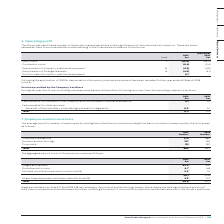According to Auto Trader's financial document, Why are some of the items identified by the group considered material? due to the significance of their nature and/or amount. These are listed separately here to provide a better understanding of the financial performance of the Group. The document states: "s identified a number of items which are material due to the significance of their nature and/or amount. These are listed separately here to provide a..." Also, What item in the table has been restated for 2018? Following the application of IFRS 16, depreciation of property, plant and equipment has been restated. The document states: "Following the application of IFRS 16, depreciation of property, plant and equipment has been restated for the year ended 31 March 2018 (note 2)...." Also, For which years was Depreciation of property, plant and equipment calculated? The document shows two values: 2019 and 2018. From the document: "Group plc Annual Report and Financial Statements 2019 | 103 (Restated) 2018 £m..." Additionally, In which year were staff costs larger? According to the financial document, 2019. The relevant text states: "Group plc Annual Report and Financial Statements 2019 | 103..." Also, can you calculate: What was the change in staff costs in 2019 from 2018? Based on the calculation: -56.0-(-54.5), the result is -1.5 (in millions). This is based on the information: "Staff costs 7 (56.0) (54.5) Staff costs 7 (56.0) (54.5)..." The key data points involved are: 54.5, 56.0. Also, can you calculate: What was the percentage change in staff costs in 2019 from 2018? To answer this question, I need to perform calculations using the financial data. The calculation is: (-56.0-(-54.5))/-54.5, which equals 2.75 (percentage). This is based on the information: "Staff costs 7 (56.0) (54.5) Staff costs 7 (56.0) (54.5)..." The key data points involved are: 54.5, 56.0. 